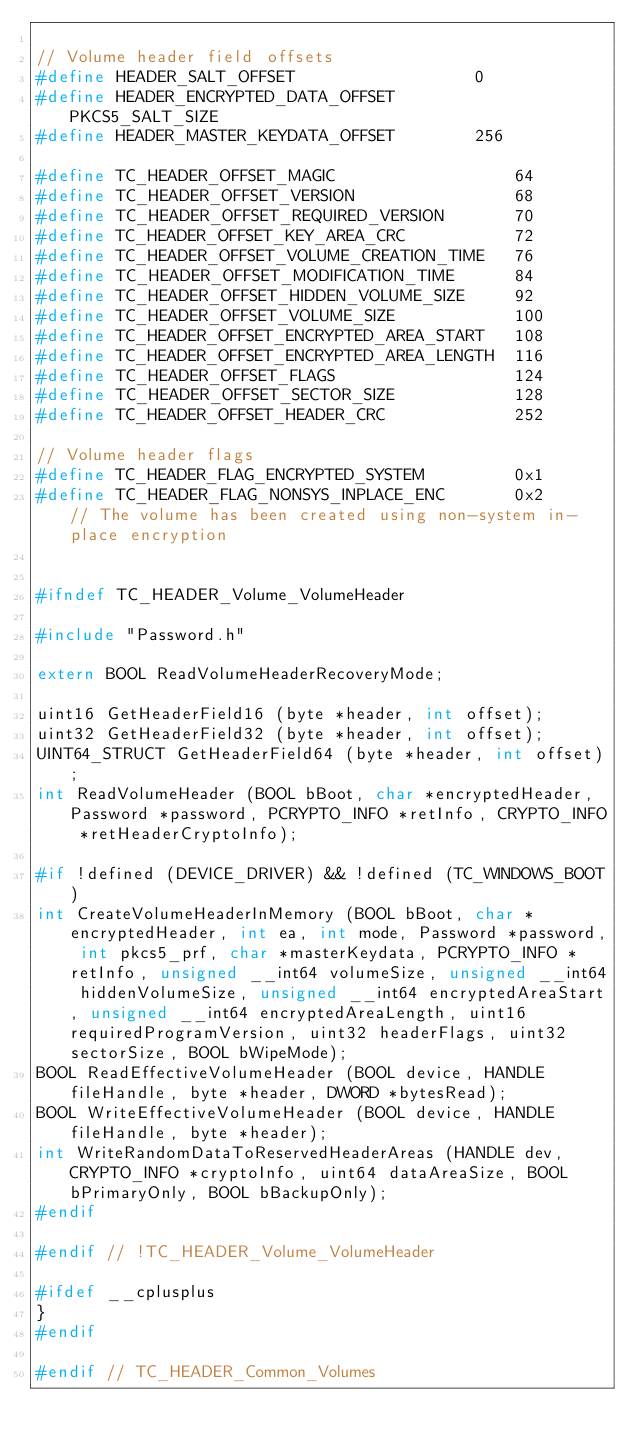<code> <loc_0><loc_0><loc_500><loc_500><_C_>
// Volume header field offsets
#define	HEADER_SALT_OFFSET					0
#define HEADER_ENCRYPTED_DATA_OFFSET		PKCS5_SALT_SIZE
#define	HEADER_MASTER_KEYDATA_OFFSET		256
	
#define TC_HEADER_OFFSET_MAGIC					64
#define TC_HEADER_OFFSET_VERSION				68
#define TC_HEADER_OFFSET_REQUIRED_VERSION		70
#define TC_HEADER_OFFSET_KEY_AREA_CRC			72
#define TC_HEADER_OFFSET_VOLUME_CREATION_TIME	76
#define TC_HEADER_OFFSET_MODIFICATION_TIME		84
#define TC_HEADER_OFFSET_HIDDEN_VOLUME_SIZE		92
#define TC_HEADER_OFFSET_VOLUME_SIZE			100
#define TC_HEADER_OFFSET_ENCRYPTED_AREA_START	108
#define TC_HEADER_OFFSET_ENCRYPTED_AREA_LENGTH	116
#define TC_HEADER_OFFSET_FLAGS					124
#define TC_HEADER_OFFSET_SECTOR_SIZE			128
#define TC_HEADER_OFFSET_HEADER_CRC				252

// Volume header flags
#define TC_HEADER_FLAG_ENCRYPTED_SYSTEM			0x1
#define TC_HEADER_FLAG_NONSYS_INPLACE_ENC		0x2		// The volume has been created using non-system in-place encryption


#ifndef TC_HEADER_Volume_VolumeHeader

#include "Password.h"

extern BOOL ReadVolumeHeaderRecoveryMode;

uint16 GetHeaderField16 (byte *header, int offset);
uint32 GetHeaderField32 (byte *header, int offset);
UINT64_STRUCT GetHeaderField64 (byte *header, int offset);
int ReadVolumeHeader (BOOL bBoot, char *encryptedHeader, Password *password, PCRYPTO_INFO *retInfo, CRYPTO_INFO *retHeaderCryptoInfo);

#if !defined (DEVICE_DRIVER) && !defined (TC_WINDOWS_BOOT)
int CreateVolumeHeaderInMemory (BOOL bBoot, char *encryptedHeader, int ea, int mode, Password *password, int pkcs5_prf, char *masterKeydata, PCRYPTO_INFO *retInfo, unsigned __int64 volumeSize, unsigned __int64 hiddenVolumeSize, unsigned __int64 encryptedAreaStart, unsigned __int64 encryptedAreaLength, uint16 requiredProgramVersion, uint32 headerFlags, uint32 sectorSize, BOOL bWipeMode);
BOOL ReadEffectiveVolumeHeader (BOOL device, HANDLE fileHandle, byte *header, DWORD *bytesRead);
BOOL WriteEffectiveVolumeHeader (BOOL device, HANDLE fileHandle, byte *header);
int WriteRandomDataToReservedHeaderAreas (HANDLE dev, CRYPTO_INFO *cryptoInfo, uint64 dataAreaSize, BOOL bPrimaryOnly, BOOL bBackupOnly);
#endif

#endif // !TC_HEADER_Volume_VolumeHeader

#ifdef __cplusplus
}
#endif

#endif // TC_HEADER_Common_Volumes
</code> 